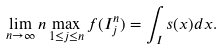<formula> <loc_0><loc_0><loc_500><loc_500>\lim _ { n \to \infty } n \max _ { 1 \leq j \leq n } f ( I _ { j } ^ { n } ) = \int _ { I } s ( x ) d x .</formula> 